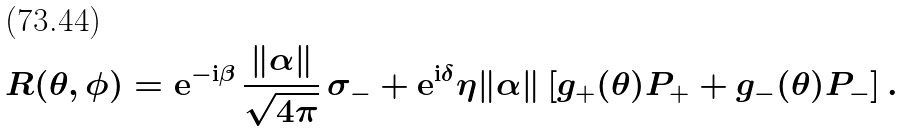<formula> <loc_0><loc_0><loc_500><loc_500>R ( \theta , \phi ) = { \mathrm e } ^ { { - \mathrm i } \beta } \, \frac { \| \alpha \| } { \sqrt { 4 \pi } } \, \sigma _ { - } + { \mathrm e } ^ { { \mathrm i } \delta } \eta \| \alpha \| \left [ g _ { + } ( \theta ) P _ { + } + g _ { - } ( \theta ) P _ { - } \right ] .</formula> 